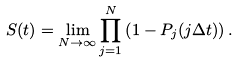<formula> <loc_0><loc_0><loc_500><loc_500>S ( t ) = \lim _ { N \rightarrow \infty } \prod _ { j = 1 } ^ { N } \left ( 1 - P _ { j } ( j \Delta t ) \right ) .</formula> 